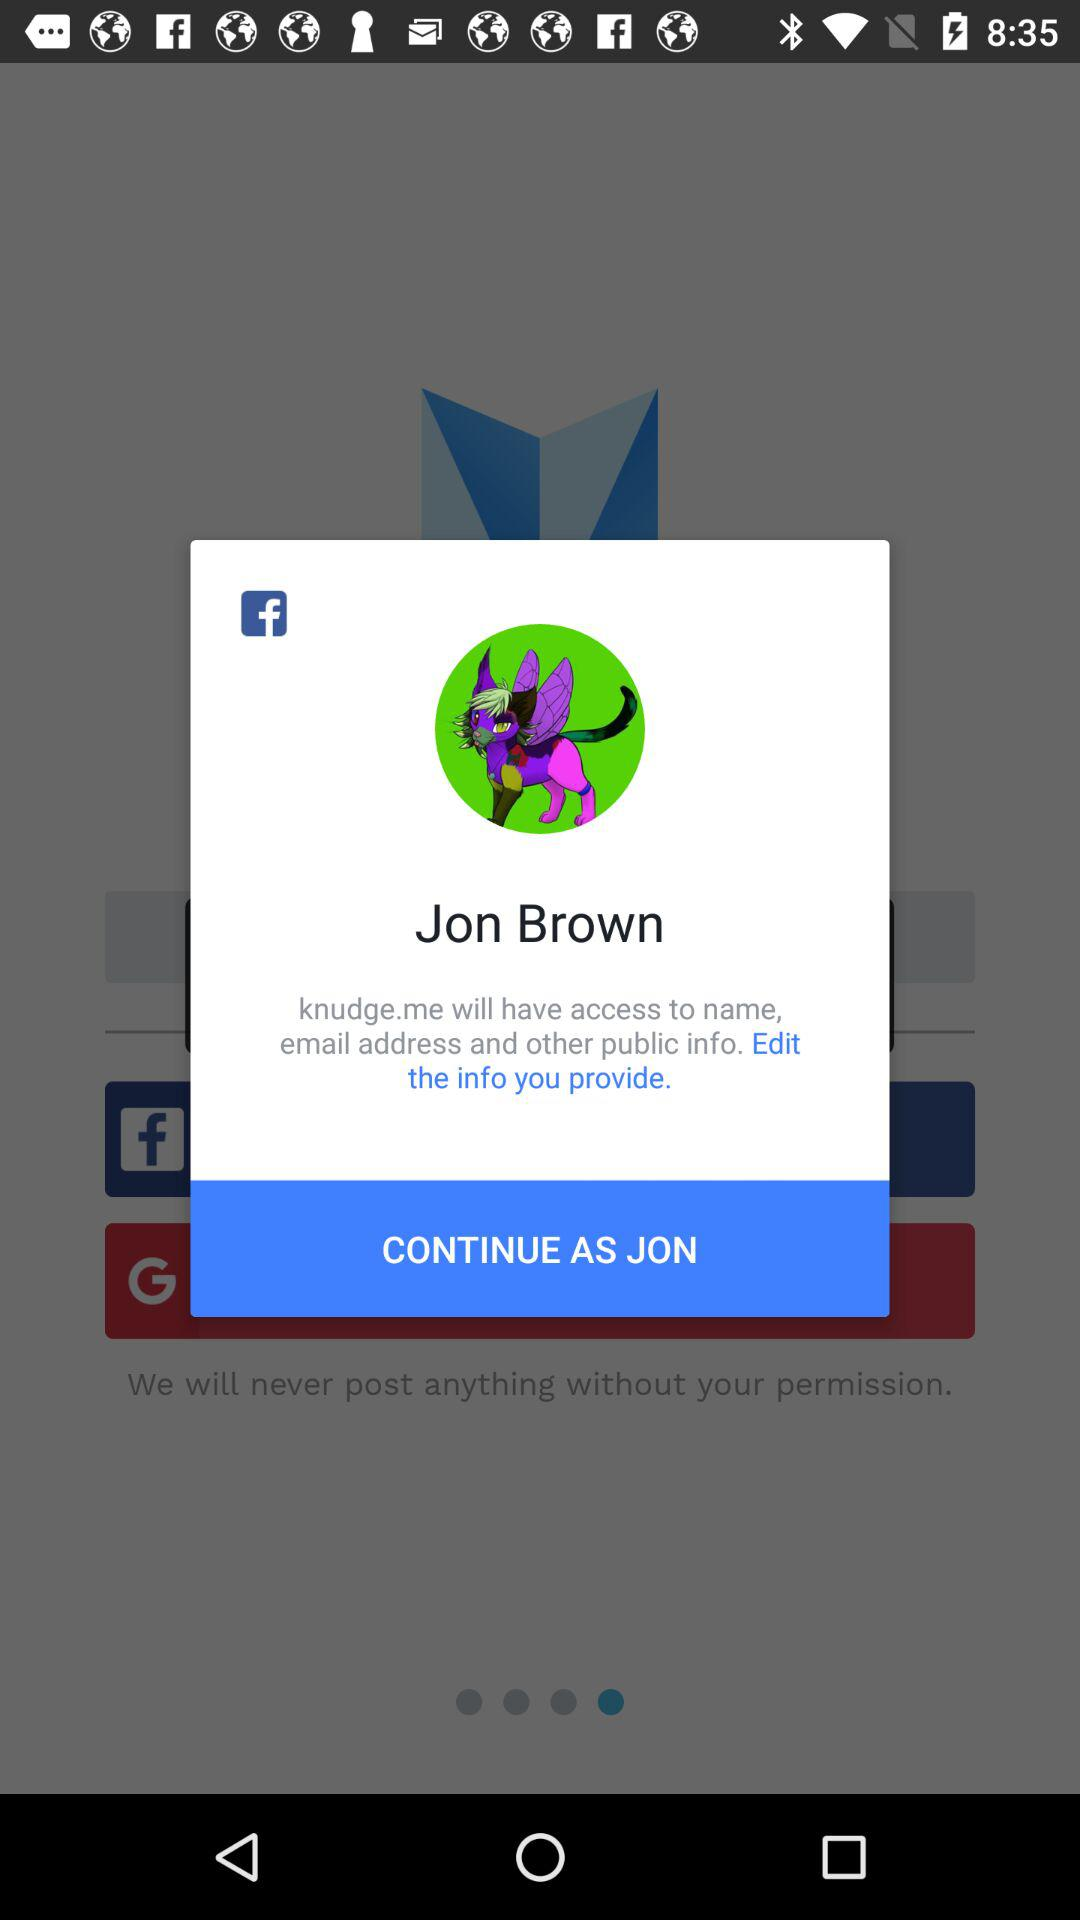What is the name of the user? The name of the user is Jon Brown. 